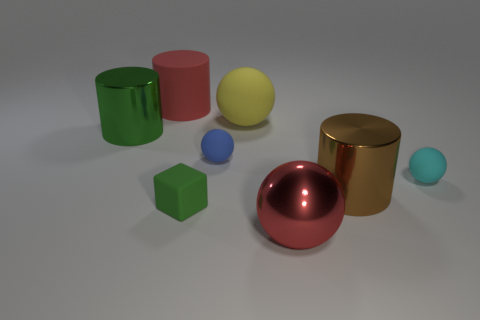Add 1 big purple spheres. How many objects exist? 9 Subtract all rubber spheres. How many spheres are left? 1 Subtract 2 spheres. How many spheres are left? 2 Subtract all cylinders. How many objects are left? 5 Subtract all cyan spheres. Subtract all gray cylinders. How many spheres are left? 3 Subtract all brown cubes. How many gray cylinders are left? 0 Subtract all red matte cubes. Subtract all green matte cubes. How many objects are left? 7 Add 2 yellow rubber balls. How many yellow rubber balls are left? 3 Add 5 green shiny blocks. How many green shiny blocks exist? 5 Subtract all yellow balls. How many balls are left? 3 